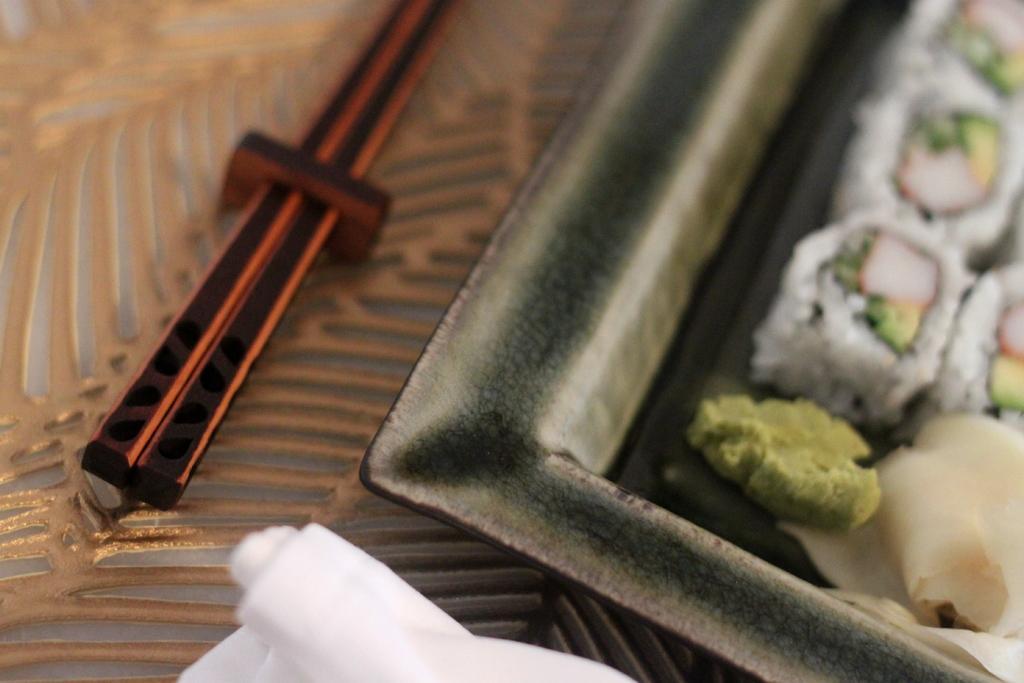Could you give a brief overview of what you see in this image? The picture consists of one plate and some food on it and beside that there are chopsticks. 